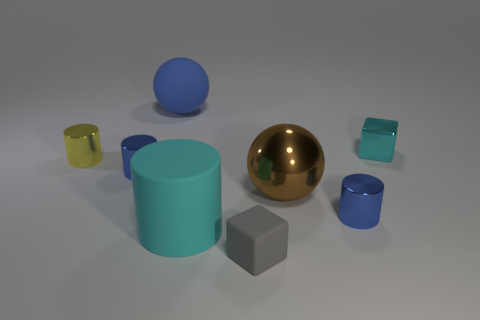What is the material of the brown thing that is the same size as the cyan rubber thing?
Give a very brief answer. Metal. Does the matte object that is on the left side of the big cyan object have the same size as the yellow cylinder that is in front of the tiny shiny block?
Give a very brief answer. No. Are there any cyan things that have the same material as the big brown thing?
Your response must be concise. Yes. How many things are either shiny cylinders that are on the right side of the large blue matte ball or gray matte objects?
Ensure brevity in your answer.  2. Is the material of the big ball on the left side of the big brown metallic thing the same as the big cyan cylinder?
Give a very brief answer. Yes. Is the tiny cyan shiny object the same shape as the big blue rubber thing?
Offer a terse response. No. There is a small metal cylinder in front of the big brown thing; what number of cyan objects are in front of it?
Provide a succinct answer. 1. What material is the other object that is the same shape as the gray object?
Your response must be concise. Metal. There is a big matte thing that is in front of the cyan shiny thing; is its color the same as the small metallic block?
Ensure brevity in your answer.  Yes. Is the gray object made of the same material as the ball behind the cyan cube?
Give a very brief answer. Yes. 